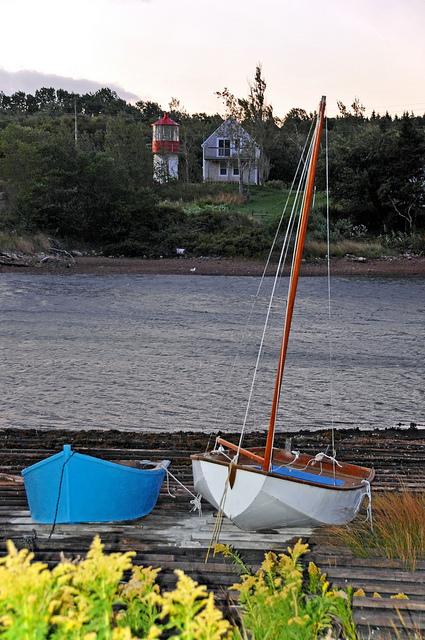Does the sailboat have a sail?
Give a very brief answer. No. Is there a house in the background?
Quick response, please. Yes. What is to the left of the sailboat?
Give a very brief answer. Boat. 